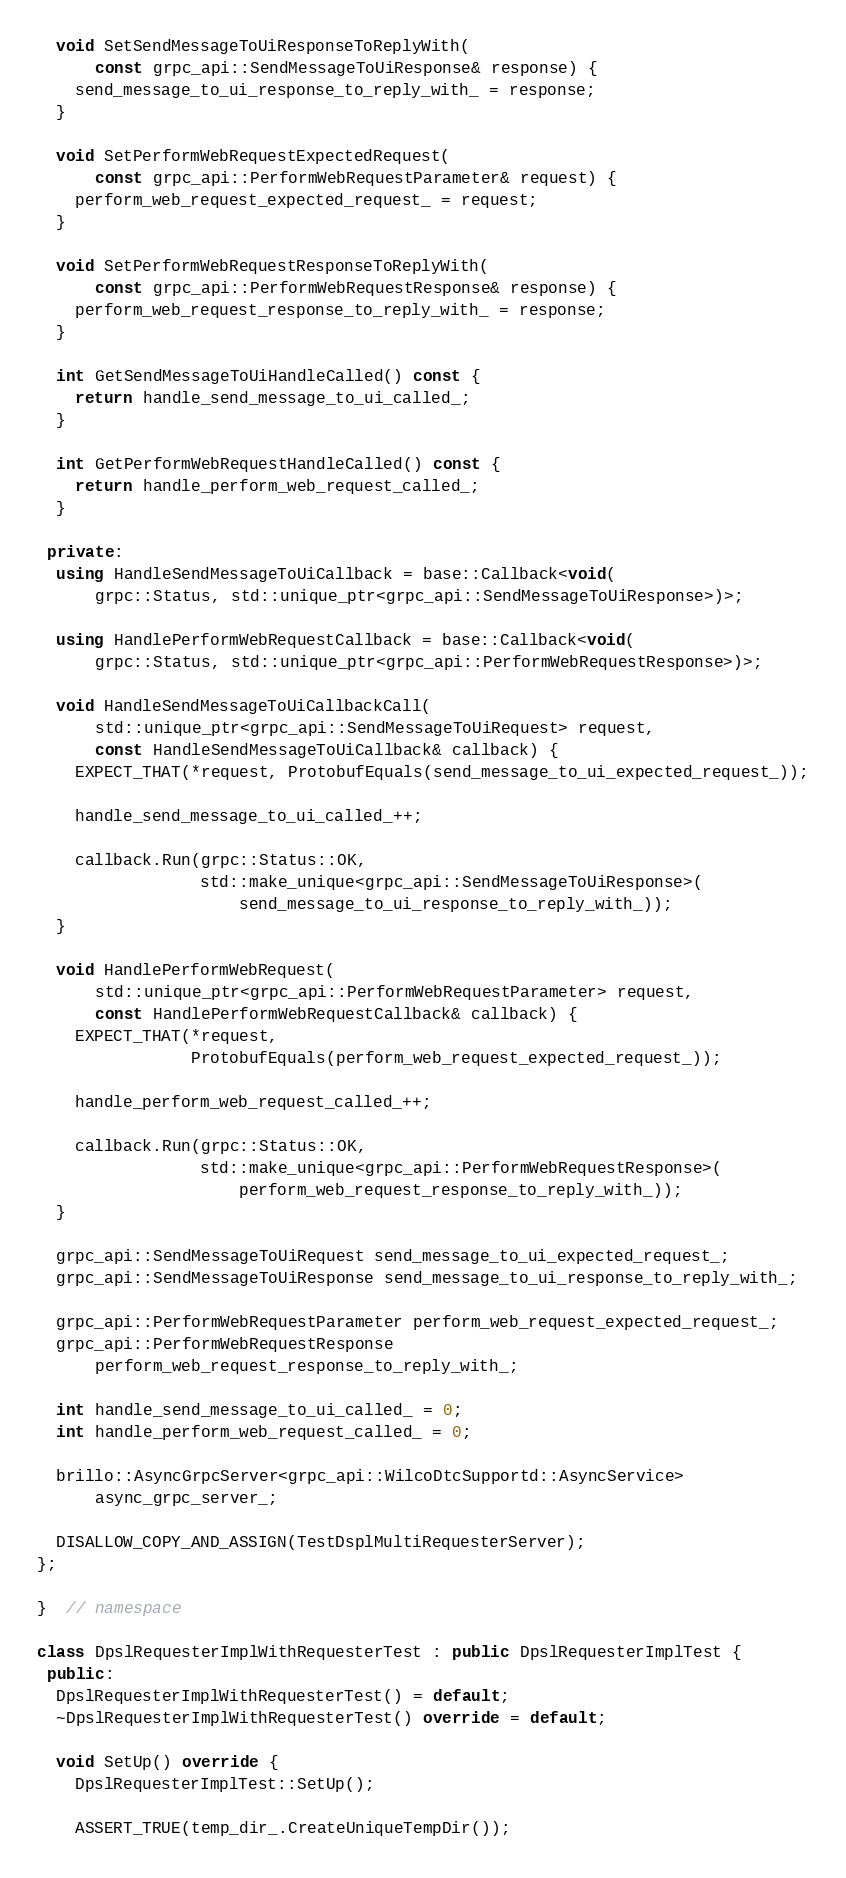<code> <loc_0><loc_0><loc_500><loc_500><_C++_>
  void SetSendMessageToUiResponseToReplyWith(
      const grpc_api::SendMessageToUiResponse& response) {
    send_message_to_ui_response_to_reply_with_ = response;
  }

  void SetPerformWebRequestExpectedRequest(
      const grpc_api::PerformWebRequestParameter& request) {
    perform_web_request_expected_request_ = request;
  }

  void SetPerformWebRequestResponseToReplyWith(
      const grpc_api::PerformWebRequestResponse& response) {
    perform_web_request_response_to_reply_with_ = response;
  }

  int GetSendMessageToUiHandleCalled() const {
    return handle_send_message_to_ui_called_;
  }

  int GetPerformWebRequestHandleCalled() const {
    return handle_perform_web_request_called_;
  }

 private:
  using HandleSendMessageToUiCallback = base::Callback<void(
      grpc::Status, std::unique_ptr<grpc_api::SendMessageToUiResponse>)>;

  using HandlePerformWebRequestCallback = base::Callback<void(
      grpc::Status, std::unique_ptr<grpc_api::PerformWebRequestResponse>)>;

  void HandleSendMessageToUiCallbackCall(
      std::unique_ptr<grpc_api::SendMessageToUiRequest> request,
      const HandleSendMessageToUiCallback& callback) {
    EXPECT_THAT(*request, ProtobufEquals(send_message_to_ui_expected_request_));

    handle_send_message_to_ui_called_++;

    callback.Run(grpc::Status::OK,
                 std::make_unique<grpc_api::SendMessageToUiResponse>(
                     send_message_to_ui_response_to_reply_with_));
  }

  void HandlePerformWebRequest(
      std::unique_ptr<grpc_api::PerformWebRequestParameter> request,
      const HandlePerformWebRequestCallback& callback) {
    EXPECT_THAT(*request,
                ProtobufEquals(perform_web_request_expected_request_));

    handle_perform_web_request_called_++;

    callback.Run(grpc::Status::OK,
                 std::make_unique<grpc_api::PerformWebRequestResponse>(
                     perform_web_request_response_to_reply_with_));
  }

  grpc_api::SendMessageToUiRequest send_message_to_ui_expected_request_;
  grpc_api::SendMessageToUiResponse send_message_to_ui_response_to_reply_with_;

  grpc_api::PerformWebRequestParameter perform_web_request_expected_request_;
  grpc_api::PerformWebRequestResponse
      perform_web_request_response_to_reply_with_;

  int handle_send_message_to_ui_called_ = 0;
  int handle_perform_web_request_called_ = 0;

  brillo::AsyncGrpcServer<grpc_api::WilcoDtcSupportd::AsyncService>
      async_grpc_server_;

  DISALLOW_COPY_AND_ASSIGN(TestDsplMultiRequesterServer);
};

}  // namespace

class DpslRequesterImplWithRequesterTest : public DpslRequesterImplTest {
 public:
  DpslRequesterImplWithRequesterTest() = default;
  ~DpslRequesterImplWithRequesterTest() override = default;

  void SetUp() override {
    DpslRequesterImplTest::SetUp();

    ASSERT_TRUE(temp_dir_.CreateUniqueTempDir());
</code> 